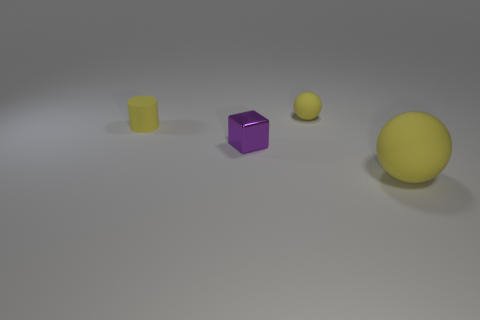Add 3 purple metallic things. How many objects exist? 7 Subtract all blocks. How many objects are left? 3 Subtract 1 cylinders. How many cylinders are left? 0 Add 3 small yellow rubber cylinders. How many small yellow rubber cylinders are left? 4 Add 4 purple metal things. How many purple metal things exist? 5 Subtract 0 brown balls. How many objects are left? 4 Subtract all gray cubes. Subtract all cyan balls. How many cubes are left? 1 Subtract all big purple shiny balls. Subtract all tiny matte objects. How many objects are left? 2 